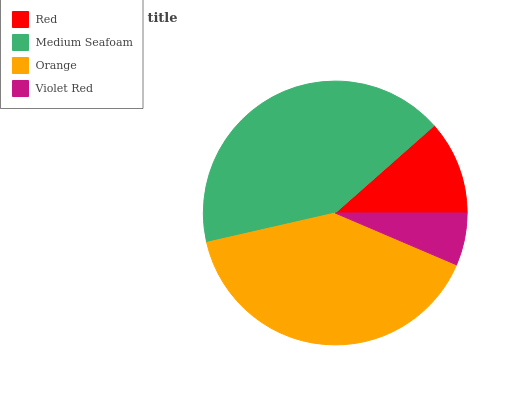Is Violet Red the minimum?
Answer yes or no. Yes. Is Medium Seafoam the maximum?
Answer yes or no. Yes. Is Orange the minimum?
Answer yes or no. No. Is Orange the maximum?
Answer yes or no. No. Is Medium Seafoam greater than Orange?
Answer yes or no. Yes. Is Orange less than Medium Seafoam?
Answer yes or no. Yes. Is Orange greater than Medium Seafoam?
Answer yes or no. No. Is Medium Seafoam less than Orange?
Answer yes or no. No. Is Orange the high median?
Answer yes or no. Yes. Is Red the low median?
Answer yes or no. Yes. Is Red the high median?
Answer yes or no. No. Is Medium Seafoam the low median?
Answer yes or no. No. 